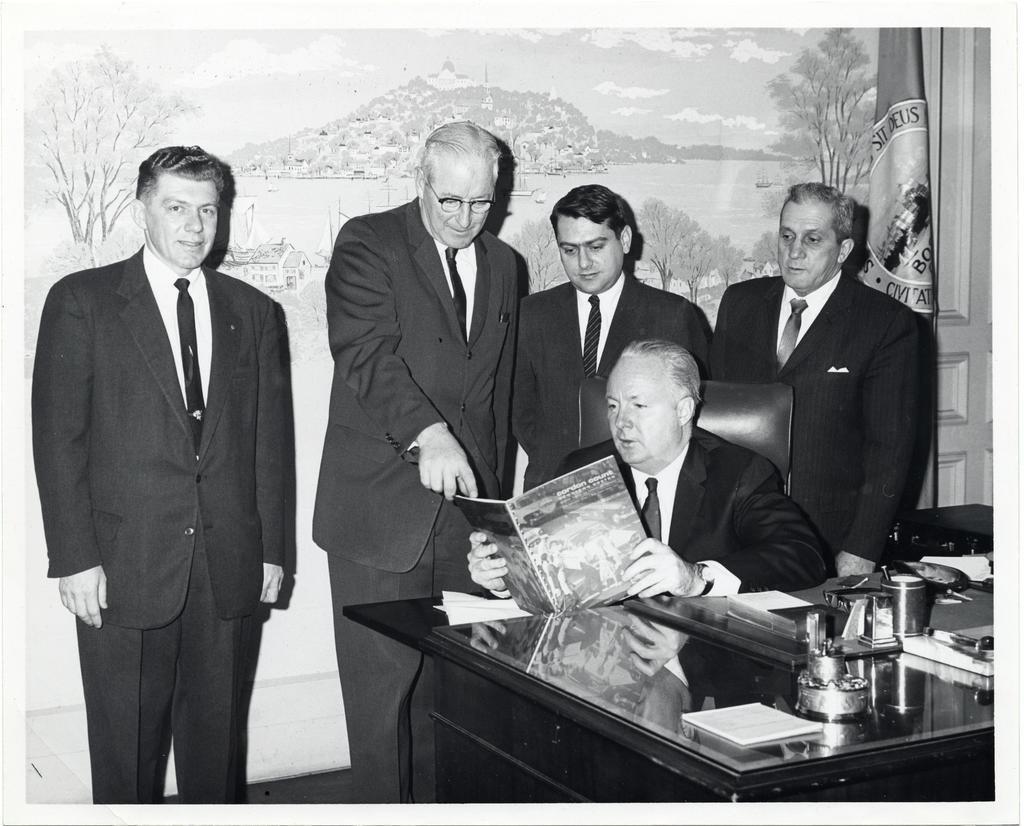How would you summarize this image in a sentence or two? This is a black and white image. Here a man sitting on the chair, holding a book in the hand and looking into the book. On the right side there is a table on which few objects are placed. At the back of this man four men are standing. In the background there is a photo frame, flag and also a door. 